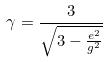<formula> <loc_0><loc_0><loc_500><loc_500>\gamma = \frac { 3 } { \sqrt { 3 - \frac { e ^ { 2 } } { g ^ { 2 } } } }</formula> 